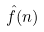<formula> <loc_0><loc_0><loc_500><loc_500>\hat { f } ( n )</formula> 